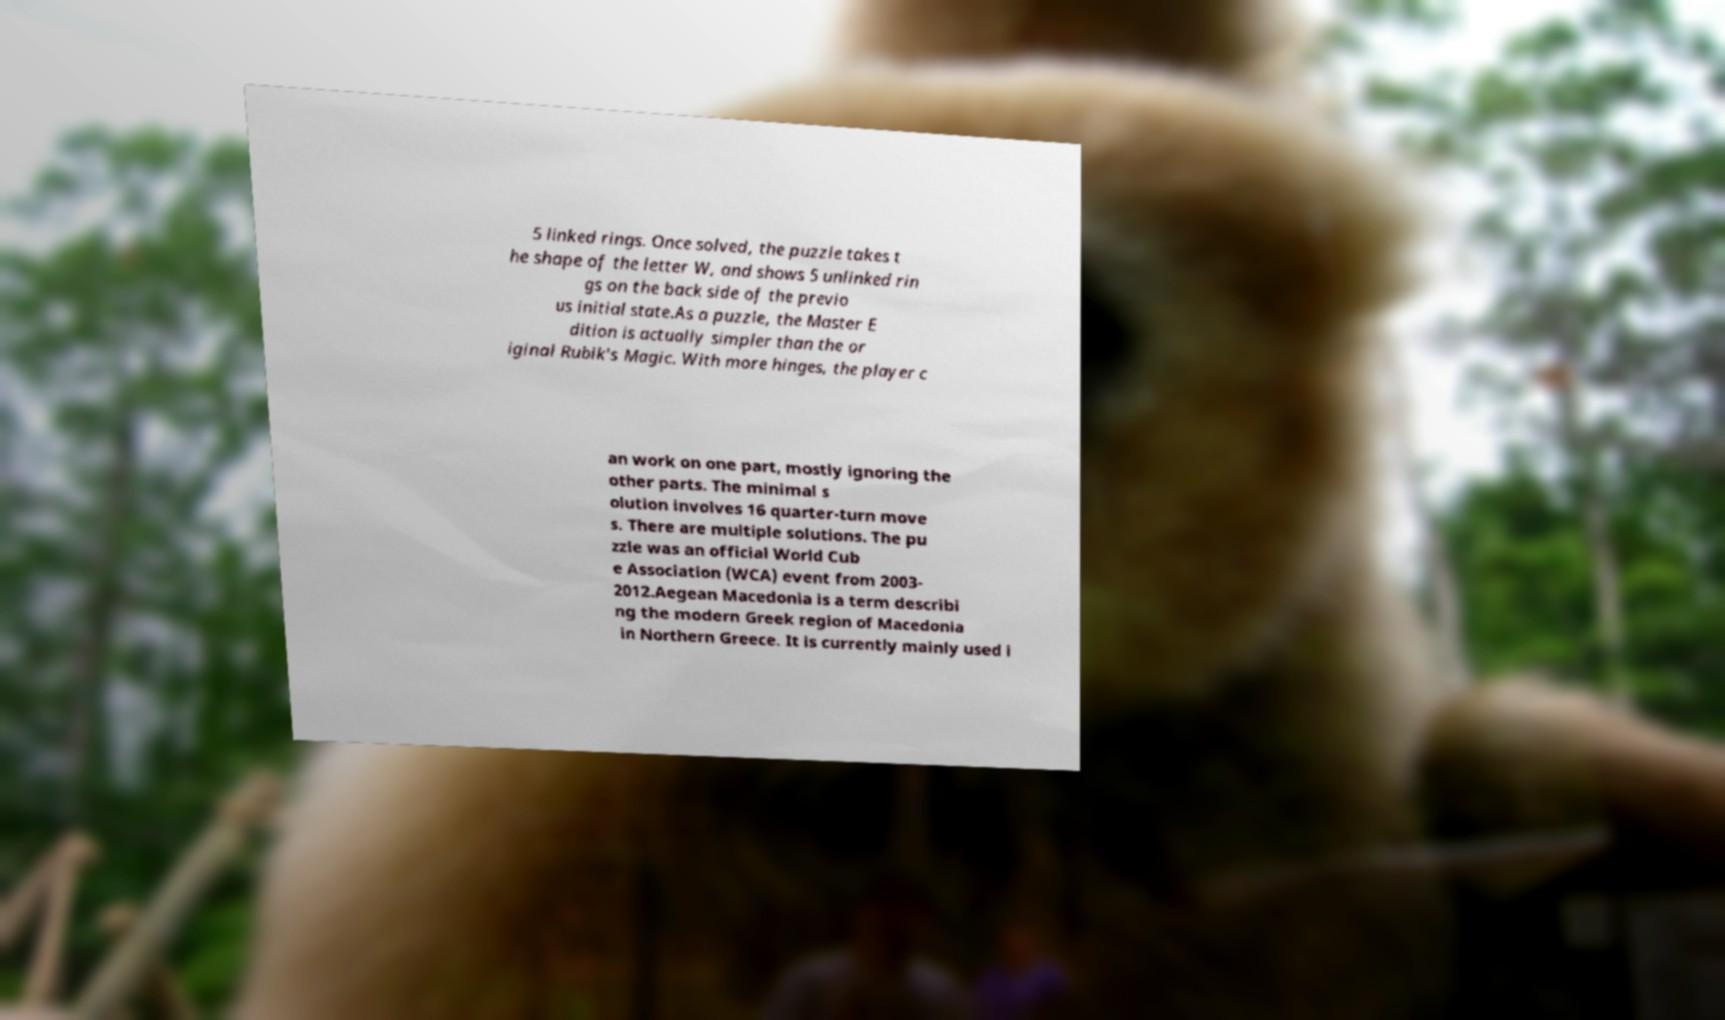Can you accurately transcribe the text from the provided image for me? 5 linked rings. Once solved, the puzzle takes t he shape of the letter W, and shows 5 unlinked rin gs on the back side of the previo us initial state.As a puzzle, the Master E dition is actually simpler than the or iginal Rubik's Magic. With more hinges, the player c an work on one part, mostly ignoring the other parts. The minimal s olution involves 16 quarter-turn move s. There are multiple solutions. The pu zzle was an official World Cub e Association (WCA) event from 2003- 2012.Aegean Macedonia is a term describi ng the modern Greek region of Macedonia in Northern Greece. It is currently mainly used i 